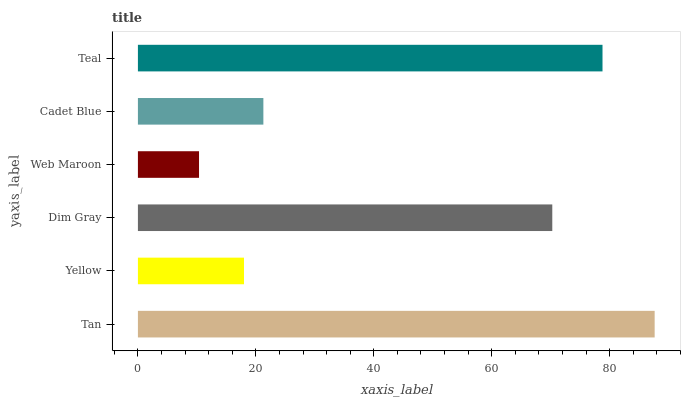Is Web Maroon the minimum?
Answer yes or no. Yes. Is Tan the maximum?
Answer yes or no. Yes. Is Yellow the minimum?
Answer yes or no. No. Is Yellow the maximum?
Answer yes or no. No. Is Tan greater than Yellow?
Answer yes or no. Yes. Is Yellow less than Tan?
Answer yes or no. Yes. Is Yellow greater than Tan?
Answer yes or no. No. Is Tan less than Yellow?
Answer yes or no. No. Is Dim Gray the high median?
Answer yes or no. Yes. Is Cadet Blue the low median?
Answer yes or no. Yes. Is Tan the high median?
Answer yes or no. No. Is Web Maroon the low median?
Answer yes or no. No. 